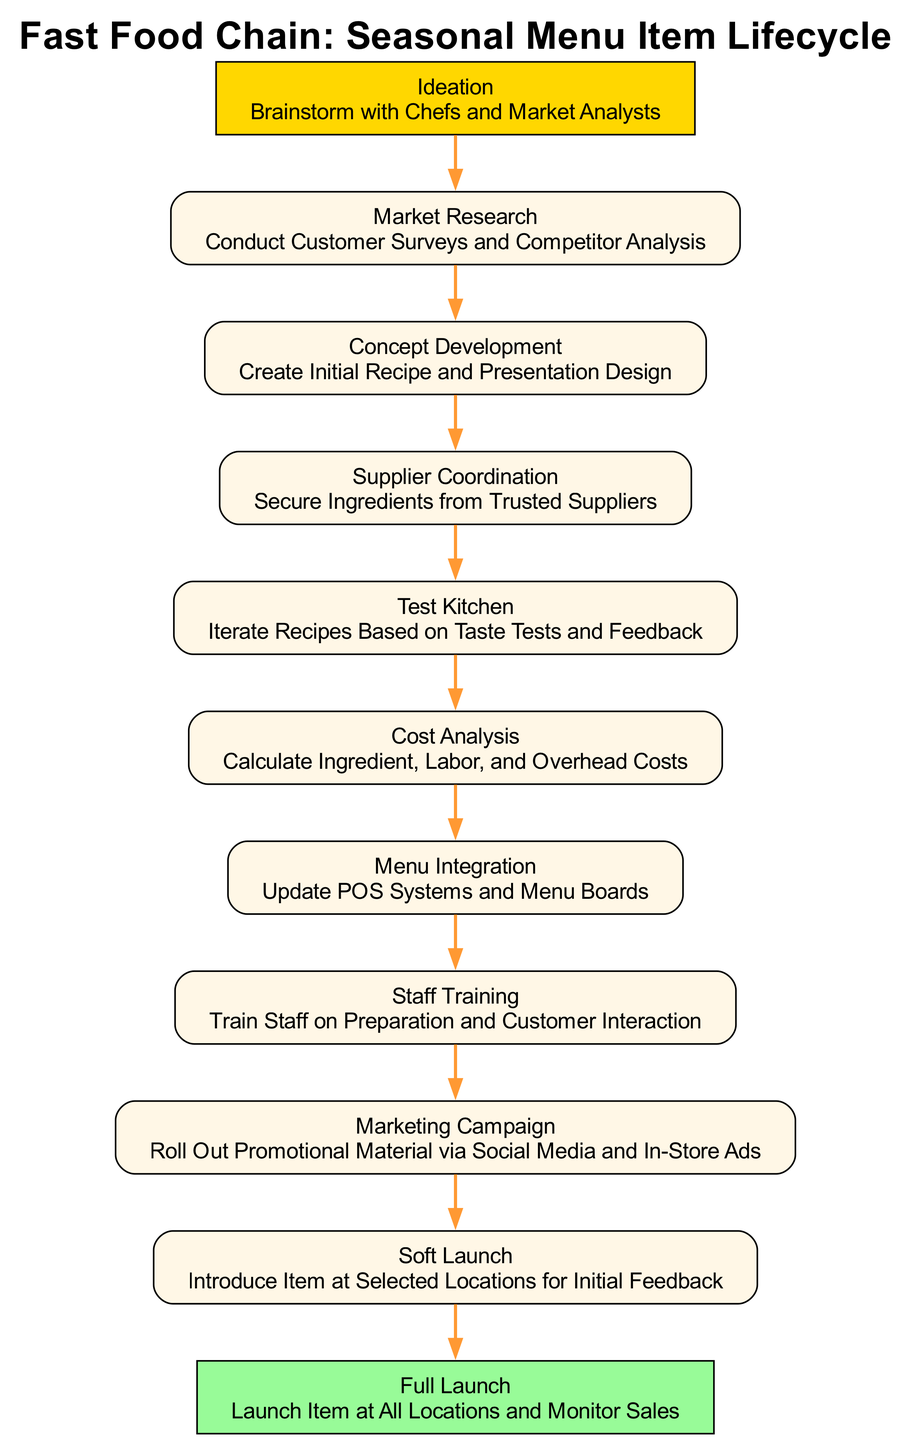What is the first step in the lifecycle? The first step in the lifecycle is labeled "Ideation", which involves brainstorming with chefs and market analysts.
Answer: Ideation How many steps are there in the lifecycle? By counting the number of listed steps in the diagram, we find that there are a total of eleven steps.
Answer: Eleven What is the last step in the process? The last step in the process is labeled "Full Launch", which indicates the final rollout of the seasonal item.
Answer: Full Launch What action follows "Supplier Coordination"? Following "Supplier Coordination", the next step is "Test Kitchen", where recipes are iterated based on taste tests and feedback.
Answer: Test Kitchen Which step involves calculating costs? The step that involves calculating costs is labeled "Cost Analysis", where ingredient, labor, and overhead costs are considered.
Answer: Cost Analysis What is the purpose of the "Marketing Campaign"? The purpose of the "Marketing Campaign" is to roll out promotional material via social media and in-store advertisements.
Answer: Roll out promotional material Which step directly leads to "Soft Launch"? The step that directly leads to "Soft Launch" is "Staff Training", where the staff is prepared for the item introduction.
Answer: Staff Training What step comes before "Menu Integration"? Before "Menu Integration", the step is "Cost Analysis", where essential financial evaluations are completed.
Answer: Cost Analysis How does the diagram represent the progression through the steps? The diagram represents the progression through the steps with directed edges connecting each successive step, indicating the order in which they occur.
Answer: Directed edges 